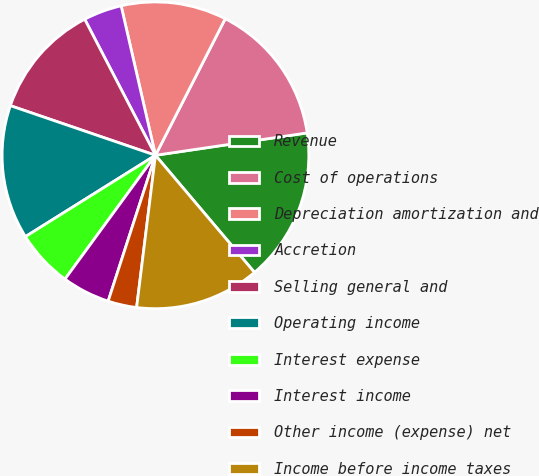Convert chart. <chart><loc_0><loc_0><loc_500><loc_500><pie_chart><fcel>Revenue<fcel>Cost of operations<fcel>Depreciation amortization and<fcel>Accretion<fcel>Selling general and<fcel>Operating income<fcel>Interest expense<fcel>Interest income<fcel>Other income (expense) net<fcel>Income before income taxes<nl><fcel>16.16%<fcel>15.15%<fcel>11.11%<fcel>4.04%<fcel>12.12%<fcel>14.14%<fcel>6.06%<fcel>5.05%<fcel>3.03%<fcel>13.13%<nl></chart> 